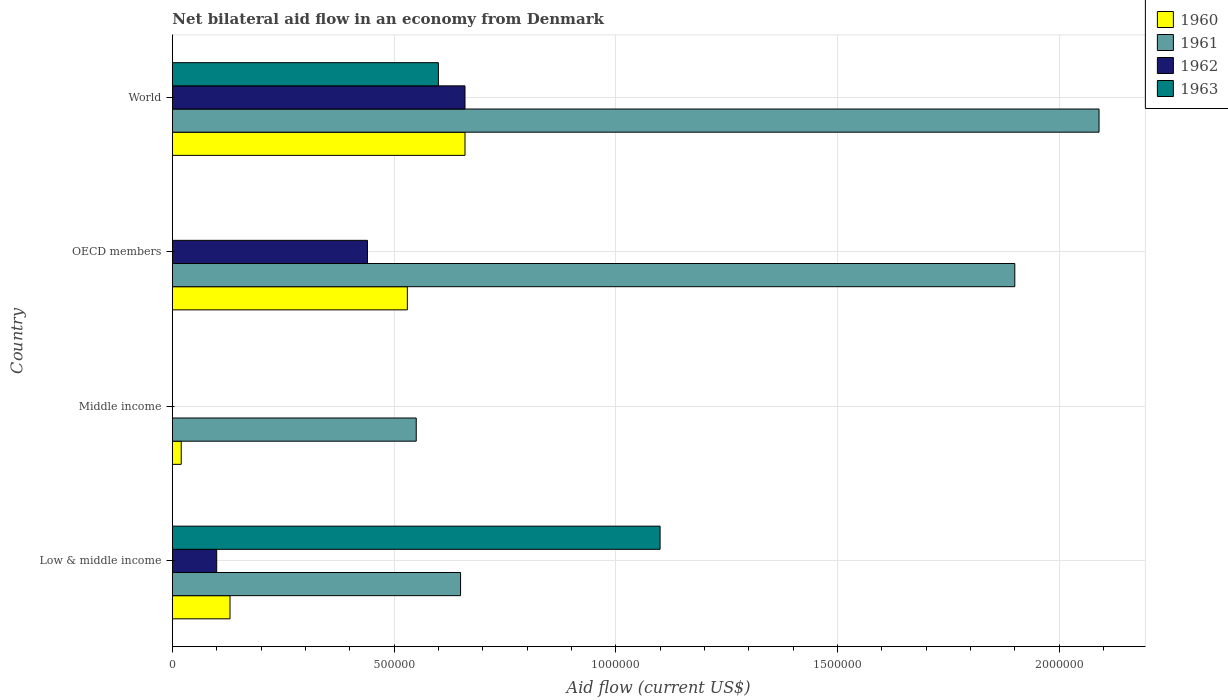Are the number of bars per tick equal to the number of legend labels?
Your answer should be very brief. No. Are the number of bars on each tick of the Y-axis equal?
Offer a very short reply. No. How many bars are there on the 2nd tick from the top?
Give a very brief answer. 3. In how many cases, is the number of bars for a given country not equal to the number of legend labels?
Your answer should be compact. 2. What is the net bilateral aid flow in 1962 in Middle income?
Your answer should be very brief. 0. Across all countries, what is the maximum net bilateral aid flow in 1962?
Provide a succinct answer. 6.60e+05. What is the total net bilateral aid flow in 1963 in the graph?
Your answer should be very brief. 1.70e+06. What is the difference between the net bilateral aid flow in 1963 in OECD members and the net bilateral aid flow in 1961 in Middle income?
Make the answer very short. -5.50e+05. What is the average net bilateral aid flow in 1963 per country?
Make the answer very short. 4.25e+05. What is the difference between the net bilateral aid flow in 1961 and net bilateral aid flow in 1963 in Low & middle income?
Your response must be concise. -4.50e+05. In how many countries, is the net bilateral aid flow in 1960 greater than 1100000 US$?
Offer a terse response. 0. What is the ratio of the net bilateral aid flow in 1961 in Middle income to that in OECD members?
Offer a very short reply. 0.29. Is the net bilateral aid flow in 1960 in OECD members less than that in World?
Offer a very short reply. Yes. What is the difference between the highest and the lowest net bilateral aid flow in 1960?
Offer a terse response. 6.40e+05. Is it the case that in every country, the sum of the net bilateral aid flow in 1961 and net bilateral aid flow in 1962 is greater than the sum of net bilateral aid flow in 1963 and net bilateral aid flow in 1960?
Ensure brevity in your answer.  No. How many countries are there in the graph?
Your answer should be very brief. 4. Does the graph contain grids?
Your response must be concise. Yes. How many legend labels are there?
Your response must be concise. 4. How are the legend labels stacked?
Provide a short and direct response. Vertical. What is the title of the graph?
Your answer should be compact. Net bilateral aid flow in an economy from Denmark. Does "1990" appear as one of the legend labels in the graph?
Your response must be concise. No. What is the Aid flow (current US$) of 1960 in Low & middle income?
Give a very brief answer. 1.30e+05. What is the Aid flow (current US$) in 1961 in Low & middle income?
Your answer should be very brief. 6.50e+05. What is the Aid flow (current US$) in 1962 in Low & middle income?
Provide a short and direct response. 1.00e+05. What is the Aid flow (current US$) in 1963 in Low & middle income?
Offer a terse response. 1.10e+06. What is the Aid flow (current US$) of 1961 in Middle income?
Provide a succinct answer. 5.50e+05. What is the Aid flow (current US$) in 1960 in OECD members?
Give a very brief answer. 5.30e+05. What is the Aid flow (current US$) in 1961 in OECD members?
Provide a short and direct response. 1.90e+06. What is the Aid flow (current US$) in 1962 in OECD members?
Offer a terse response. 4.40e+05. What is the Aid flow (current US$) of 1963 in OECD members?
Your answer should be very brief. 0. What is the Aid flow (current US$) in 1961 in World?
Your response must be concise. 2.09e+06. What is the Aid flow (current US$) in 1963 in World?
Ensure brevity in your answer.  6.00e+05. Across all countries, what is the maximum Aid flow (current US$) of 1960?
Offer a terse response. 6.60e+05. Across all countries, what is the maximum Aid flow (current US$) in 1961?
Keep it short and to the point. 2.09e+06. Across all countries, what is the maximum Aid flow (current US$) of 1963?
Make the answer very short. 1.10e+06. Across all countries, what is the minimum Aid flow (current US$) in 1962?
Keep it short and to the point. 0. Across all countries, what is the minimum Aid flow (current US$) of 1963?
Your response must be concise. 0. What is the total Aid flow (current US$) of 1960 in the graph?
Provide a short and direct response. 1.34e+06. What is the total Aid flow (current US$) of 1961 in the graph?
Make the answer very short. 5.19e+06. What is the total Aid flow (current US$) in 1962 in the graph?
Provide a succinct answer. 1.20e+06. What is the total Aid flow (current US$) of 1963 in the graph?
Give a very brief answer. 1.70e+06. What is the difference between the Aid flow (current US$) in 1960 in Low & middle income and that in Middle income?
Your answer should be compact. 1.10e+05. What is the difference between the Aid flow (current US$) of 1961 in Low & middle income and that in Middle income?
Provide a short and direct response. 1.00e+05. What is the difference between the Aid flow (current US$) of 1960 in Low & middle income and that in OECD members?
Give a very brief answer. -4.00e+05. What is the difference between the Aid flow (current US$) in 1961 in Low & middle income and that in OECD members?
Your answer should be very brief. -1.25e+06. What is the difference between the Aid flow (current US$) of 1962 in Low & middle income and that in OECD members?
Provide a short and direct response. -3.40e+05. What is the difference between the Aid flow (current US$) of 1960 in Low & middle income and that in World?
Your answer should be compact. -5.30e+05. What is the difference between the Aid flow (current US$) in 1961 in Low & middle income and that in World?
Your answer should be very brief. -1.44e+06. What is the difference between the Aid flow (current US$) in 1962 in Low & middle income and that in World?
Offer a very short reply. -5.60e+05. What is the difference between the Aid flow (current US$) in 1963 in Low & middle income and that in World?
Your answer should be compact. 5.00e+05. What is the difference between the Aid flow (current US$) in 1960 in Middle income and that in OECD members?
Offer a terse response. -5.10e+05. What is the difference between the Aid flow (current US$) in 1961 in Middle income and that in OECD members?
Your response must be concise. -1.35e+06. What is the difference between the Aid flow (current US$) of 1960 in Middle income and that in World?
Give a very brief answer. -6.40e+05. What is the difference between the Aid flow (current US$) of 1961 in Middle income and that in World?
Your answer should be compact. -1.54e+06. What is the difference between the Aid flow (current US$) in 1961 in OECD members and that in World?
Offer a terse response. -1.90e+05. What is the difference between the Aid flow (current US$) in 1962 in OECD members and that in World?
Your response must be concise. -2.20e+05. What is the difference between the Aid flow (current US$) of 1960 in Low & middle income and the Aid flow (current US$) of 1961 in Middle income?
Offer a very short reply. -4.20e+05. What is the difference between the Aid flow (current US$) of 1960 in Low & middle income and the Aid flow (current US$) of 1961 in OECD members?
Provide a succinct answer. -1.77e+06. What is the difference between the Aid flow (current US$) in 1960 in Low & middle income and the Aid flow (current US$) in 1962 in OECD members?
Your response must be concise. -3.10e+05. What is the difference between the Aid flow (current US$) of 1960 in Low & middle income and the Aid flow (current US$) of 1961 in World?
Offer a terse response. -1.96e+06. What is the difference between the Aid flow (current US$) in 1960 in Low & middle income and the Aid flow (current US$) in 1962 in World?
Give a very brief answer. -5.30e+05. What is the difference between the Aid flow (current US$) of 1960 in Low & middle income and the Aid flow (current US$) of 1963 in World?
Offer a very short reply. -4.70e+05. What is the difference between the Aid flow (current US$) of 1962 in Low & middle income and the Aid flow (current US$) of 1963 in World?
Your answer should be compact. -5.00e+05. What is the difference between the Aid flow (current US$) of 1960 in Middle income and the Aid flow (current US$) of 1961 in OECD members?
Offer a terse response. -1.88e+06. What is the difference between the Aid flow (current US$) of 1960 in Middle income and the Aid flow (current US$) of 1962 in OECD members?
Offer a very short reply. -4.20e+05. What is the difference between the Aid flow (current US$) in 1961 in Middle income and the Aid flow (current US$) in 1962 in OECD members?
Your answer should be very brief. 1.10e+05. What is the difference between the Aid flow (current US$) of 1960 in Middle income and the Aid flow (current US$) of 1961 in World?
Offer a terse response. -2.07e+06. What is the difference between the Aid flow (current US$) of 1960 in Middle income and the Aid flow (current US$) of 1962 in World?
Give a very brief answer. -6.40e+05. What is the difference between the Aid flow (current US$) in 1960 in Middle income and the Aid flow (current US$) in 1963 in World?
Ensure brevity in your answer.  -5.80e+05. What is the difference between the Aid flow (current US$) of 1961 in Middle income and the Aid flow (current US$) of 1962 in World?
Keep it short and to the point. -1.10e+05. What is the difference between the Aid flow (current US$) in 1960 in OECD members and the Aid flow (current US$) in 1961 in World?
Your answer should be compact. -1.56e+06. What is the difference between the Aid flow (current US$) in 1960 in OECD members and the Aid flow (current US$) in 1962 in World?
Your response must be concise. -1.30e+05. What is the difference between the Aid flow (current US$) of 1961 in OECD members and the Aid flow (current US$) of 1962 in World?
Offer a very short reply. 1.24e+06. What is the difference between the Aid flow (current US$) in 1961 in OECD members and the Aid flow (current US$) in 1963 in World?
Your response must be concise. 1.30e+06. What is the difference between the Aid flow (current US$) of 1962 in OECD members and the Aid flow (current US$) of 1963 in World?
Your answer should be compact. -1.60e+05. What is the average Aid flow (current US$) in 1960 per country?
Keep it short and to the point. 3.35e+05. What is the average Aid flow (current US$) in 1961 per country?
Give a very brief answer. 1.30e+06. What is the average Aid flow (current US$) of 1963 per country?
Provide a succinct answer. 4.25e+05. What is the difference between the Aid flow (current US$) of 1960 and Aid flow (current US$) of 1961 in Low & middle income?
Ensure brevity in your answer.  -5.20e+05. What is the difference between the Aid flow (current US$) of 1960 and Aid flow (current US$) of 1962 in Low & middle income?
Give a very brief answer. 3.00e+04. What is the difference between the Aid flow (current US$) in 1960 and Aid flow (current US$) in 1963 in Low & middle income?
Give a very brief answer. -9.70e+05. What is the difference between the Aid flow (current US$) of 1961 and Aid flow (current US$) of 1962 in Low & middle income?
Provide a succinct answer. 5.50e+05. What is the difference between the Aid flow (current US$) in 1961 and Aid flow (current US$) in 1963 in Low & middle income?
Keep it short and to the point. -4.50e+05. What is the difference between the Aid flow (current US$) of 1960 and Aid flow (current US$) of 1961 in Middle income?
Your response must be concise. -5.30e+05. What is the difference between the Aid flow (current US$) in 1960 and Aid flow (current US$) in 1961 in OECD members?
Make the answer very short. -1.37e+06. What is the difference between the Aid flow (current US$) of 1960 and Aid flow (current US$) of 1962 in OECD members?
Make the answer very short. 9.00e+04. What is the difference between the Aid flow (current US$) of 1961 and Aid flow (current US$) of 1962 in OECD members?
Make the answer very short. 1.46e+06. What is the difference between the Aid flow (current US$) in 1960 and Aid flow (current US$) in 1961 in World?
Your answer should be compact. -1.43e+06. What is the difference between the Aid flow (current US$) in 1960 and Aid flow (current US$) in 1963 in World?
Ensure brevity in your answer.  6.00e+04. What is the difference between the Aid flow (current US$) of 1961 and Aid flow (current US$) of 1962 in World?
Ensure brevity in your answer.  1.43e+06. What is the difference between the Aid flow (current US$) of 1961 and Aid flow (current US$) of 1963 in World?
Provide a short and direct response. 1.49e+06. What is the difference between the Aid flow (current US$) in 1962 and Aid flow (current US$) in 1963 in World?
Your response must be concise. 6.00e+04. What is the ratio of the Aid flow (current US$) of 1960 in Low & middle income to that in Middle income?
Your answer should be compact. 6.5. What is the ratio of the Aid flow (current US$) of 1961 in Low & middle income to that in Middle income?
Make the answer very short. 1.18. What is the ratio of the Aid flow (current US$) in 1960 in Low & middle income to that in OECD members?
Keep it short and to the point. 0.25. What is the ratio of the Aid flow (current US$) of 1961 in Low & middle income to that in OECD members?
Offer a terse response. 0.34. What is the ratio of the Aid flow (current US$) in 1962 in Low & middle income to that in OECD members?
Your response must be concise. 0.23. What is the ratio of the Aid flow (current US$) of 1960 in Low & middle income to that in World?
Ensure brevity in your answer.  0.2. What is the ratio of the Aid flow (current US$) in 1961 in Low & middle income to that in World?
Ensure brevity in your answer.  0.31. What is the ratio of the Aid flow (current US$) of 1962 in Low & middle income to that in World?
Offer a terse response. 0.15. What is the ratio of the Aid flow (current US$) in 1963 in Low & middle income to that in World?
Your answer should be compact. 1.83. What is the ratio of the Aid flow (current US$) in 1960 in Middle income to that in OECD members?
Give a very brief answer. 0.04. What is the ratio of the Aid flow (current US$) of 1961 in Middle income to that in OECD members?
Keep it short and to the point. 0.29. What is the ratio of the Aid flow (current US$) of 1960 in Middle income to that in World?
Keep it short and to the point. 0.03. What is the ratio of the Aid flow (current US$) of 1961 in Middle income to that in World?
Provide a succinct answer. 0.26. What is the ratio of the Aid flow (current US$) of 1960 in OECD members to that in World?
Give a very brief answer. 0.8. What is the ratio of the Aid flow (current US$) of 1961 in OECD members to that in World?
Ensure brevity in your answer.  0.91. What is the ratio of the Aid flow (current US$) of 1962 in OECD members to that in World?
Keep it short and to the point. 0.67. What is the difference between the highest and the second highest Aid flow (current US$) in 1961?
Give a very brief answer. 1.90e+05. What is the difference between the highest and the lowest Aid flow (current US$) in 1960?
Ensure brevity in your answer.  6.40e+05. What is the difference between the highest and the lowest Aid flow (current US$) of 1961?
Your response must be concise. 1.54e+06. What is the difference between the highest and the lowest Aid flow (current US$) of 1963?
Your response must be concise. 1.10e+06. 